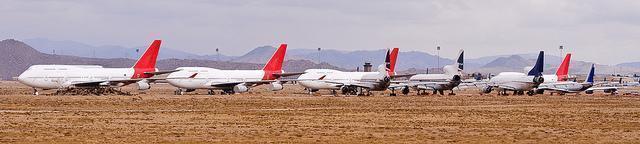What is the main factor keeping the planes on the dirt?
Make your selection from the four choices given to correctly answer the question.
Options: Aerodynamics, age, production, gas. Age. 